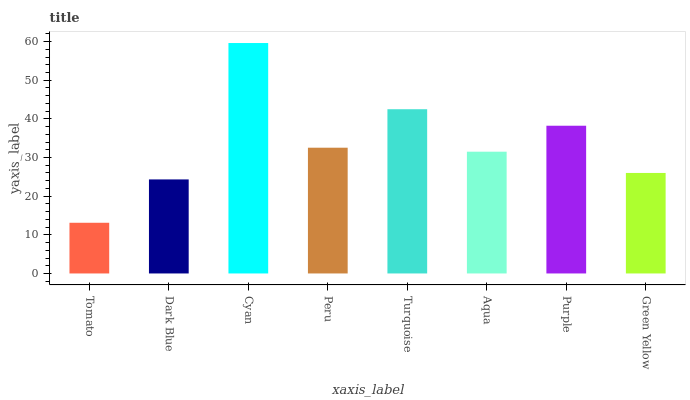Is Tomato the minimum?
Answer yes or no. Yes. Is Cyan the maximum?
Answer yes or no. Yes. Is Dark Blue the minimum?
Answer yes or no. No. Is Dark Blue the maximum?
Answer yes or no. No. Is Dark Blue greater than Tomato?
Answer yes or no. Yes. Is Tomato less than Dark Blue?
Answer yes or no. Yes. Is Tomato greater than Dark Blue?
Answer yes or no. No. Is Dark Blue less than Tomato?
Answer yes or no. No. Is Peru the high median?
Answer yes or no. Yes. Is Aqua the low median?
Answer yes or no. Yes. Is Dark Blue the high median?
Answer yes or no. No. Is Purple the low median?
Answer yes or no. No. 